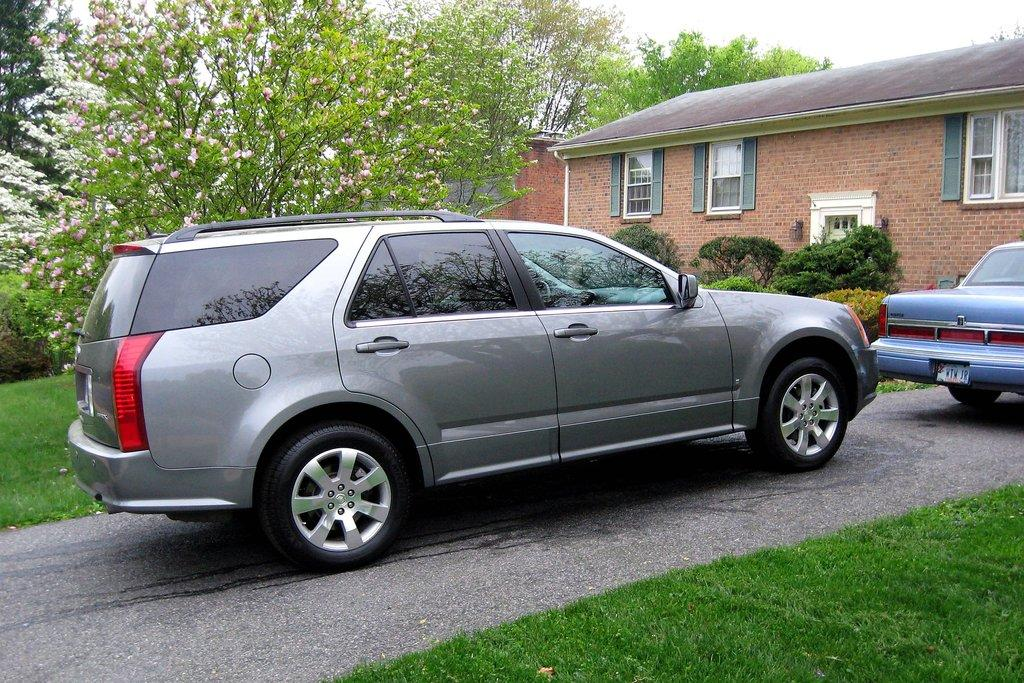What is the main subject of the image? The main subject of the image is a car on the road. What can be seen on the right side of the image? There is a house on the right side of the image. What type of vegetation is on the left side of the image? There are trees on the left side of the image. What type of plough is the farmer using in the image? There is no farmer or plough present in the image; it features a car on the road, a house on the right side, and trees on the left side. 